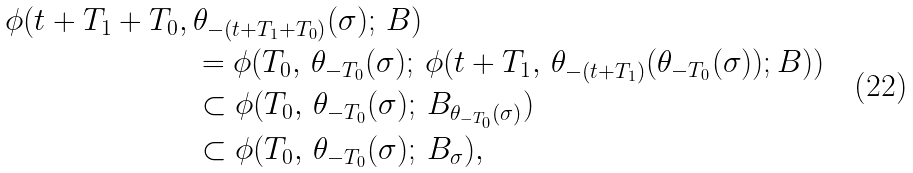<formula> <loc_0><loc_0><loc_500><loc_500>\phi ( t + T _ { 1 } + T _ { 0 } , \, & \theta _ { - ( t + T _ { 1 } + T _ { 0 } ) } ( \sigma ) ; \, B ) \\ & = \phi ( T _ { 0 } , \, \theta _ { - T _ { 0 } } ( \sigma ) ; \, \phi ( t + T _ { 1 } , \, \theta _ { - ( t + T _ { 1 } ) } ( \theta _ { - T _ { 0 } } ( \sigma ) ) ; B ) ) \\ & \subset \phi ( T _ { 0 } , \, \theta _ { - T _ { 0 } } ( \sigma ) ; \, B _ { \theta _ { - T _ { 0 } } ( \sigma ) } ) \\ & \subset \phi ( T _ { 0 } , \, \theta _ { - T _ { 0 } } ( \sigma ) ; \, B _ { \sigma } ) ,</formula> 